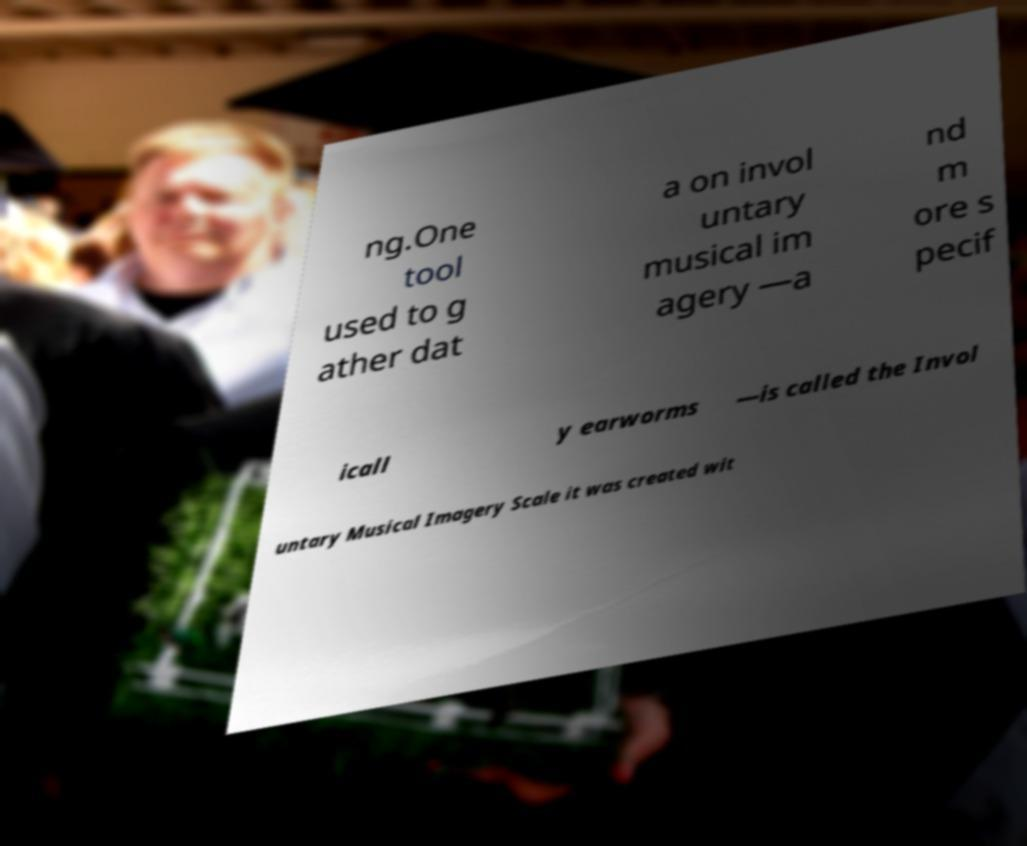Could you assist in decoding the text presented in this image and type it out clearly? ng.One tool used to g ather dat a on invol untary musical im agery —a nd m ore s pecif icall y earworms —is called the Invol untary Musical Imagery Scale it was created wit 